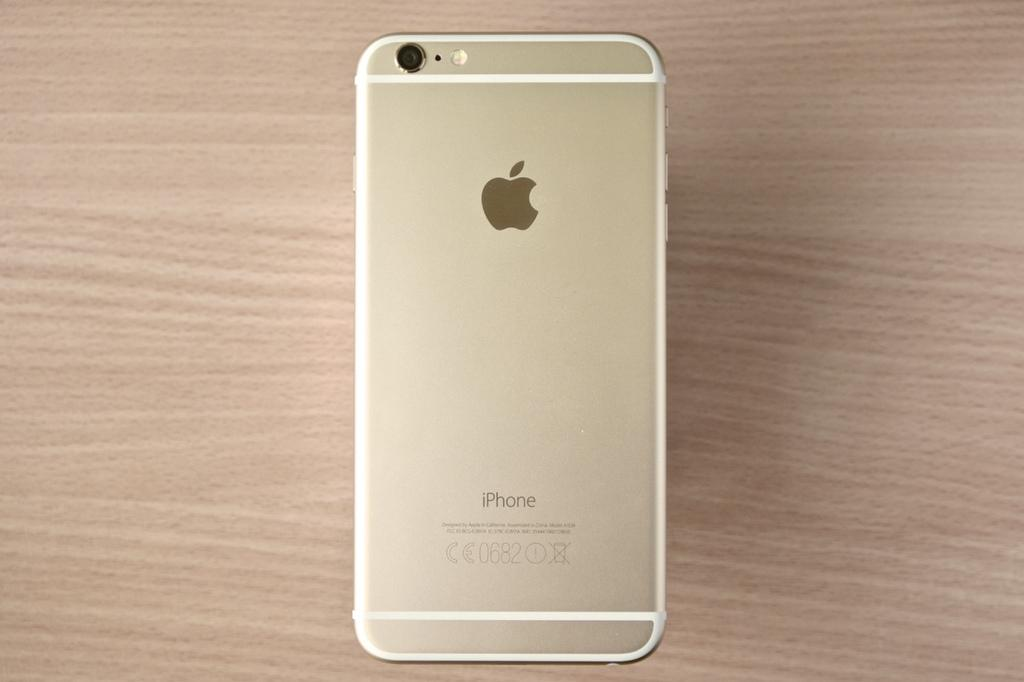Provide a one-sentence caption for the provided image. An iPhone is laying face down on a wooden surface. 